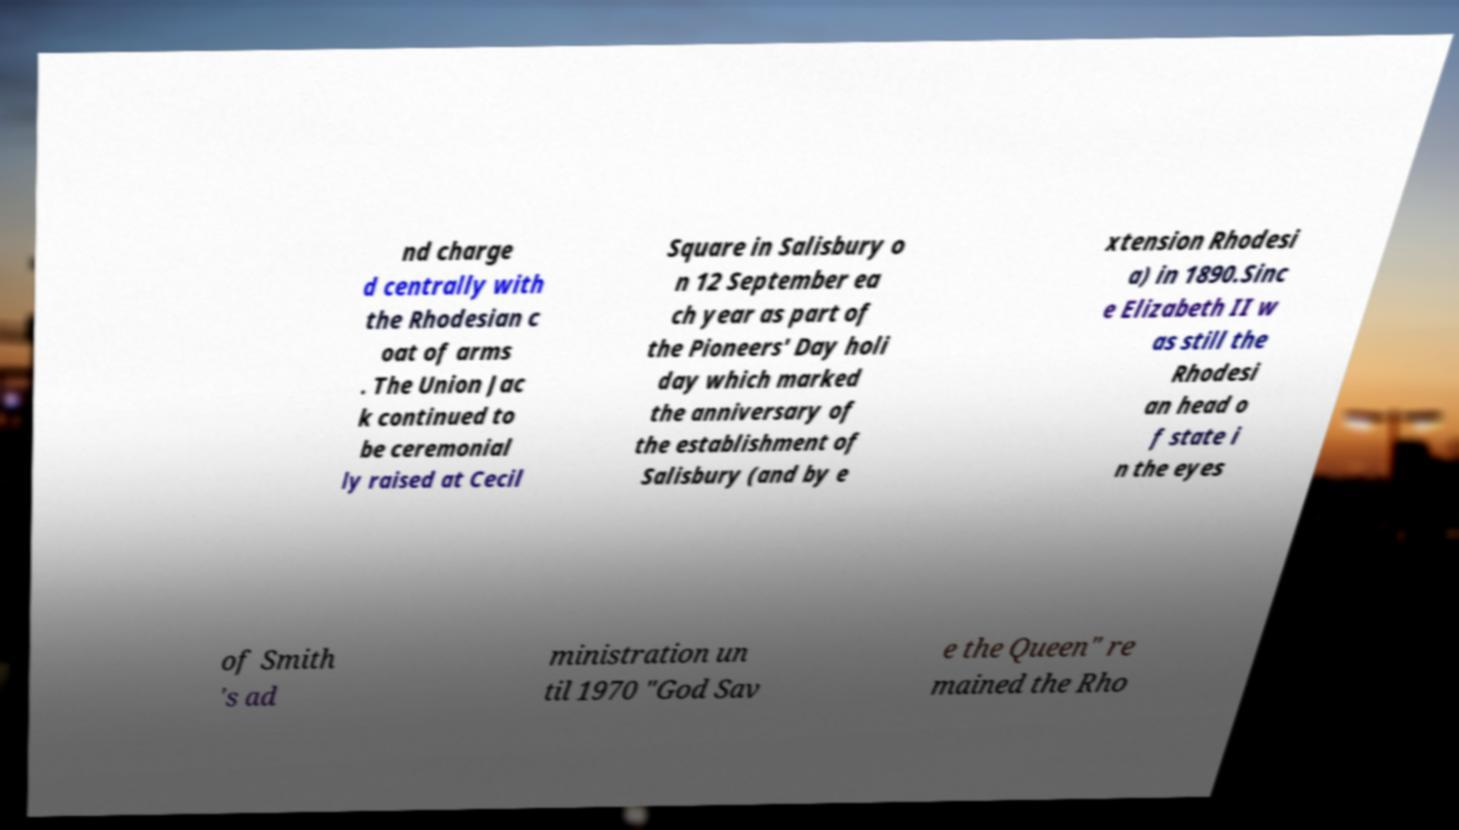What messages or text are displayed in this image? I need them in a readable, typed format. nd charge d centrally with the Rhodesian c oat of arms . The Union Jac k continued to be ceremonial ly raised at Cecil Square in Salisbury o n 12 September ea ch year as part of the Pioneers' Day holi day which marked the anniversary of the establishment of Salisbury (and by e xtension Rhodesi a) in 1890.Sinc e Elizabeth II w as still the Rhodesi an head o f state i n the eyes of Smith 's ad ministration un til 1970 "God Sav e the Queen" re mained the Rho 